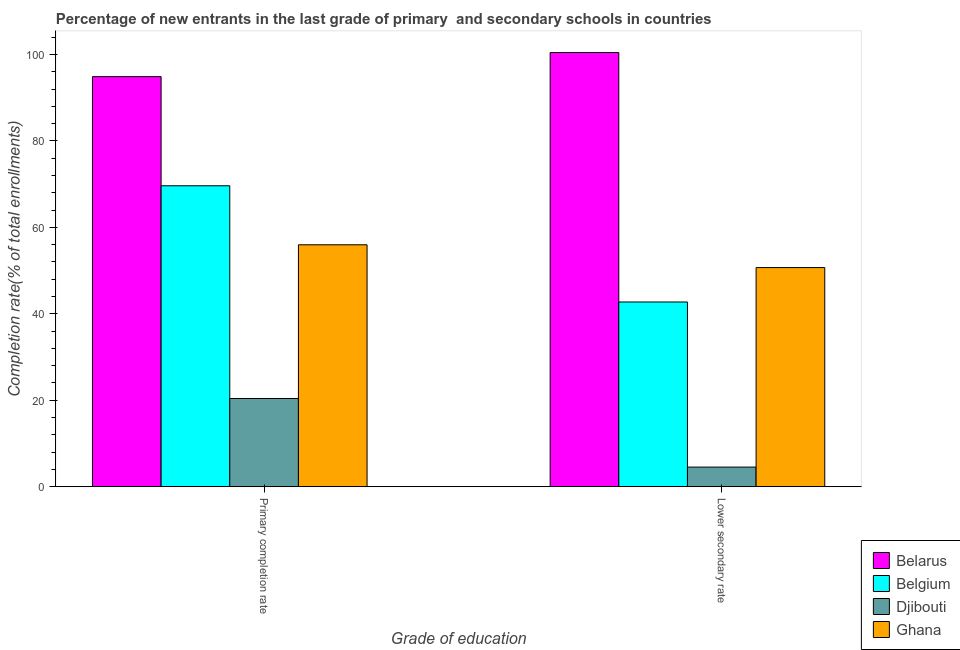Are the number of bars per tick equal to the number of legend labels?
Provide a short and direct response. Yes. Are the number of bars on each tick of the X-axis equal?
Give a very brief answer. Yes. How many bars are there on the 1st tick from the left?
Your answer should be very brief. 4. What is the label of the 1st group of bars from the left?
Ensure brevity in your answer.  Primary completion rate. What is the completion rate in primary schools in Belarus?
Keep it short and to the point. 94.87. Across all countries, what is the maximum completion rate in secondary schools?
Your answer should be compact. 100.45. Across all countries, what is the minimum completion rate in secondary schools?
Ensure brevity in your answer.  4.54. In which country was the completion rate in secondary schools maximum?
Your answer should be very brief. Belarus. In which country was the completion rate in primary schools minimum?
Make the answer very short. Djibouti. What is the total completion rate in primary schools in the graph?
Ensure brevity in your answer.  240.87. What is the difference between the completion rate in secondary schools in Belarus and that in Ghana?
Provide a short and direct response. 49.75. What is the difference between the completion rate in primary schools in Ghana and the completion rate in secondary schools in Djibouti?
Your answer should be compact. 51.43. What is the average completion rate in primary schools per country?
Your answer should be compact. 60.22. What is the difference between the completion rate in secondary schools and completion rate in primary schools in Ghana?
Offer a terse response. -5.27. What is the ratio of the completion rate in primary schools in Belgium to that in Belarus?
Provide a succinct answer. 0.73. In how many countries, is the completion rate in secondary schools greater than the average completion rate in secondary schools taken over all countries?
Provide a short and direct response. 2. What does the 4th bar from the left in Primary completion rate represents?
Ensure brevity in your answer.  Ghana. How many bars are there?
Give a very brief answer. 8. How many countries are there in the graph?
Offer a terse response. 4. Are the values on the major ticks of Y-axis written in scientific E-notation?
Make the answer very short. No. Does the graph contain grids?
Provide a short and direct response. No. Where does the legend appear in the graph?
Your answer should be compact. Bottom right. How many legend labels are there?
Your answer should be compact. 4. What is the title of the graph?
Offer a very short reply. Percentage of new entrants in the last grade of primary  and secondary schools in countries. What is the label or title of the X-axis?
Your answer should be compact. Grade of education. What is the label or title of the Y-axis?
Offer a very short reply. Completion rate(% of total enrollments). What is the Completion rate(% of total enrollments) in Belarus in Primary completion rate?
Provide a short and direct response. 94.87. What is the Completion rate(% of total enrollments) in Belgium in Primary completion rate?
Keep it short and to the point. 69.62. What is the Completion rate(% of total enrollments) of Djibouti in Primary completion rate?
Your response must be concise. 20.41. What is the Completion rate(% of total enrollments) in Ghana in Primary completion rate?
Ensure brevity in your answer.  55.97. What is the Completion rate(% of total enrollments) in Belarus in Lower secondary rate?
Your answer should be compact. 100.45. What is the Completion rate(% of total enrollments) of Belgium in Lower secondary rate?
Provide a succinct answer. 42.74. What is the Completion rate(% of total enrollments) of Djibouti in Lower secondary rate?
Your answer should be very brief. 4.54. What is the Completion rate(% of total enrollments) in Ghana in Lower secondary rate?
Ensure brevity in your answer.  50.7. Across all Grade of education, what is the maximum Completion rate(% of total enrollments) of Belarus?
Provide a short and direct response. 100.45. Across all Grade of education, what is the maximum Completion rate(% of total enrollments) in Belgium?
Offer a terse response. 69.62. Across all Grade of education, what is the maximum Completion rate(% of total enrollments) in Djibouti?
Your response must be concise. 20.41. Across all Grade of education, what is the maximum Completion rate(% of total enrollments) in Ghana?
Ensure brevity in your answer.  55.97. Across all Grade of education, what is the minimum Completion rate(% of total enrollments) of Belarus?
Ensure brevity in your answer.  94.87. Across all Grade of education, what is the minimum Completion rate(% of total enrollments) of Belgium?
Make the answer very short. 42.74. Across all Grade of education, what is the minimum Completion rate(% of total enrollments) in Djibouti?
Offer a very short reply. 4.54. Across all Grade of education, what is the minimum Completion rate(% of total enrollments) in Ghana?
Your answer should be very brief. 50.7. What is the total Completion rate(% of total enrollments) in Belarus in the graph?
Offer a terse response. 195.32. What is the total Completion rate(% of total enrollments) of Belgium in the graph?
Offer a very short reply. 112.36. What is the total Completion rate(% of total enrollments) in Djibouti in the graph?
Make the answer very short. 24.95. What is the total Completion rate(% of total enrollments) of Ghana in the graph?
Make the answer very short. 106.67. What is the difference between the Completion rate(% of total enrollments) in Belarus in Primary completion rate and that in Lower secondary rate?
Your response must be concise. -5.58. What is the difference between the Completion rate(% of total enrollments) of Belgium in Primary completion rate and that in Lower secondary rate?
Provide a succinct answer. 26.89. What is the difference between the Completion rate(% of total enrollments) of Djibouti in Primary completion rate and that in Lower secondary rate?
Provide a short and direct response. 15.87. What is the difference between the Completion rate(% of total enrollments) in Ghana in Primary completion rate and that in Lower secondary rate?
Give a very brief answer. 5.27. What is the difference between the Completion rate(% of total enrollments) in Belarus in Primary completion rate and the Completion rate(% of total enrollments) in Belgium in Lower secondary rate?
Provide a succinct answer. 52.14. What is the difference between the Completion rate(% of total enrollments) of Belarus in Primary completion rate and the Completion rate(% of total enrollments) of Djibouti in Lower secondary rate?
Make the answer very short. 90.33. What is the difference between the Completion rate(% of total enrollments) in Belarus in Primary completion rate and the Completion rate(% of total enrollments) in Ghana in Lower secondary rate?
Ensure brevity in your answer.  44.17. What is the difference between the Completion rate(% of total enrollments) in Belgium in Primary completion rate and the Completion rate(% of total enrollments) in Djibouti in Lower secondary rate?
Offer a terse response. 65.08. What is the difference between the Completion rate(% of total enrollments) of Belgium in Primary completion rate and the Completion rate(% of total enrollments) of Ghana in Lower secondary rate?
Give a very brief answer. 18.92. What is the difference between the Completion rate(% of total enrollments) in Djibouti in Primary completion rate and the Completion rate(% of total enrollments) in Ghana in Lower secondary rate?
Your answer should be very brief. -30.29. What is the average Completion rate(% of total enrollments) of Belarus per Grade of education?
Provide a short and direct response. 97.66. What is the average Completion rate(% of total enrollments) of Belgium per Grade of education?
Your answer should be compact. 56.18. What is the average Completion rate(% of total enrollments) in Djibouti per Grade of education?
Offer a very short reply. 12.48. What is the average Completion rate(% of total enrollments) of Ghana per Grade of education?
Ensure brevity in your answer.  53.33. What is the difference between the Completion rate(% of total enrollments) of Belarus and Completion rate(% of total enrollments) of Belgium in Primary completion rate?
Your response must be concise. 25.25. What is the difference between the Completion rate(% of total enrollments) of Belarus and Completion rate(% of total enrollments) of Djibouti in Primary completion rate?
Provide a succinct answer. 74.46. What is the difference between the Completion rate(% of total enrollments) in Belarus and Completion rate(% of total enrollments) in Ghana in Primary completion rate?
Provide a short and direct response. 38.9. What is the difference between the Completion rate(% of total enrollments) in Belgium and Completion rate(% of total enrollments) in Djibouti in Primary completion rate?
Provide a short and direct response. 49.21. What is the difference between the Completion rate(% of total enrollments) of Belgium and Completion rate(% of total enrollments) of Ghana in Primary completion rate?
Make the answer very short. 13.65. What is the difference between the Completion rate(% of total enrollments) of Djibouti and Completion rate(% of total enrollments) of Ghana in Primary completion rate?
Your answer should be compact. -35.56. What is the difference between the Completion rate(% of total enrollments) in Belarus and Completion rate(% of total enrollments) in Belgium in Lower secondary rate?
Make the answer very short. 57.71. What is the difference between the Completion rate(% of total enrollments) of Belarus and Completion rate(% of total enrollments) of Djibouti in Lower secondary rate?
Your answer should be very brief. 95.9. What is the difference between the Completion rate(% of total enrollments) in Belarus and Completion rate(% of total enrollments) in Ghana in Lower secondary rate?
Offer a very short reply. 49.75. What is the difference between the Completion rate(% of total enrollments) of Belgium and Completion rate(% of total enrollments) of Djibouti in Lower secondary rate?
Offer a terse response. 38.19. What is the difference between the Completion rate(% of total enrollments) of Belgium and Completion rate(% of total enrollments) of Ghana in Lower secondary rate?
Your answer should be compact. -7.96. What is the difference between the Completion rate(% of total enrollments) in Djibouti and Completion rate(% of total enrollments) in Ghana in Lower secondary rate?
Offer a very short reply. -46.16. What is the ratio of the Completion rate(% of total enrollments) in Belarus in Primary completion rate to that in Lower secondary rate?
Keep it short and to the point. 0.94. What is the ratio of the Completion rate(% of total enrollments) in Belgium in Primary completion rate to that in Lower secondary rate?
Give a very brief answer. 1.63. What is the ratio of the Completion rate(% of total enrollments) in Djibouti in Primary completion rate to that in Lower secondary rate?
Make the answer very short. 4.49. What is the ratio of the Completion rate(% of total enrollments) in Ghana in Primary completion rate to that in Lower secondary rate?
Your answer should be compact. 1.1. What is the difference between the highest and the second highest Completion rate(% of total enrollments) in Belarus?
Give a very brief answer. 5.58. What is the difference between the highest and the second highest Completion rate(% of total enrollments) in Belgium?
Provide a short and direct response. 26.89. What is the difference between the highest and the second highest Completion rate(% of total enrollments) of Djibouti?
Offer a terse response. 15.87. What is the difference between the highest and the second highest Completion rate(% of total enrollments) of Ghana?
Provide a short and direct response. 5.27. What is the difference between the highest and the lowest Completion rate(% of total enrollments) of Belarus?
Provide a succinct answer. 5.58. What is the difference between the highest and the lowest Completion rate(% of total enrollments) in Belgium?
Provide a succinct answer. 26.89. What is the difference between the highest and the lowest Completion rate(% of total enrollments) of Djibouti?
Make the answer very short. 15.87. What is the difference between the highest and the lowest Completion rate(% of total enrollments) in Ghana?
Make the answer very short. 5.27. 